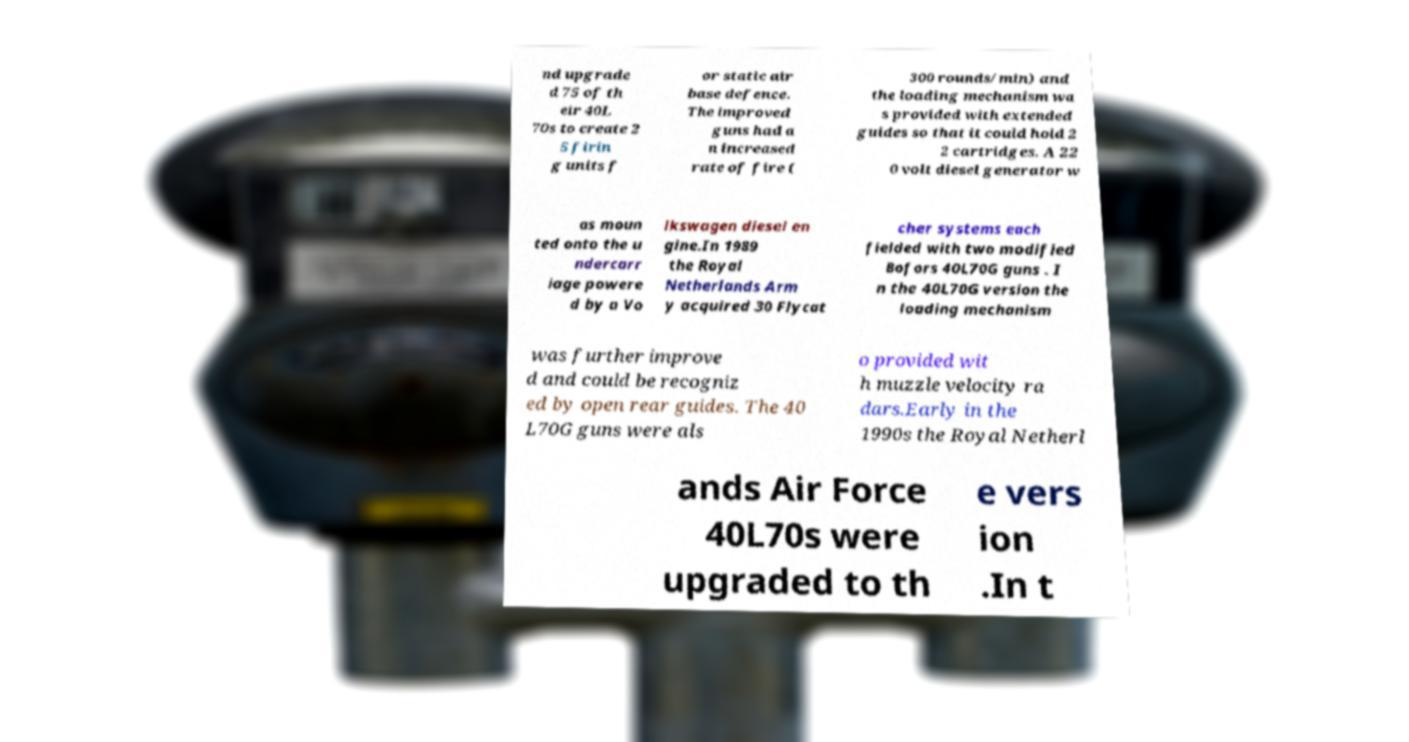I need the written content from this picture converted into text. Can you do that? nd upgrade d 75 of th eir 40L 70s to create 2 5 firin g units f or static air base defence. The improved guns had a n increased rate of fire ( 300 rounds/min) and the loading mechanism wa s provided with extended guides so that it could hold 2 2 cartridges. A 22 0 volt diesel generator w as moun ted onto the u ndercarr iage powere d by a Vo lkswagen diesel en gine.In 1989 the Royal Netherlands Arm y acquired 30 Flycat cher systems each fielded with two modified Bofors 40L70G guns . I n the 40L70G version the loading mechanism was further improve d and could be recogniz ed by open rear guides. The 40 L70G guns were als o provided wit h muzzle velocity ra dars.Early in the 1990s the Royal Netherl ands Air Force 40L70s were upgraded to th e vers ion .In t 